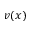<formula> <loc_0><loc_0><loc_500><loc_500>v ( x )</formula> 